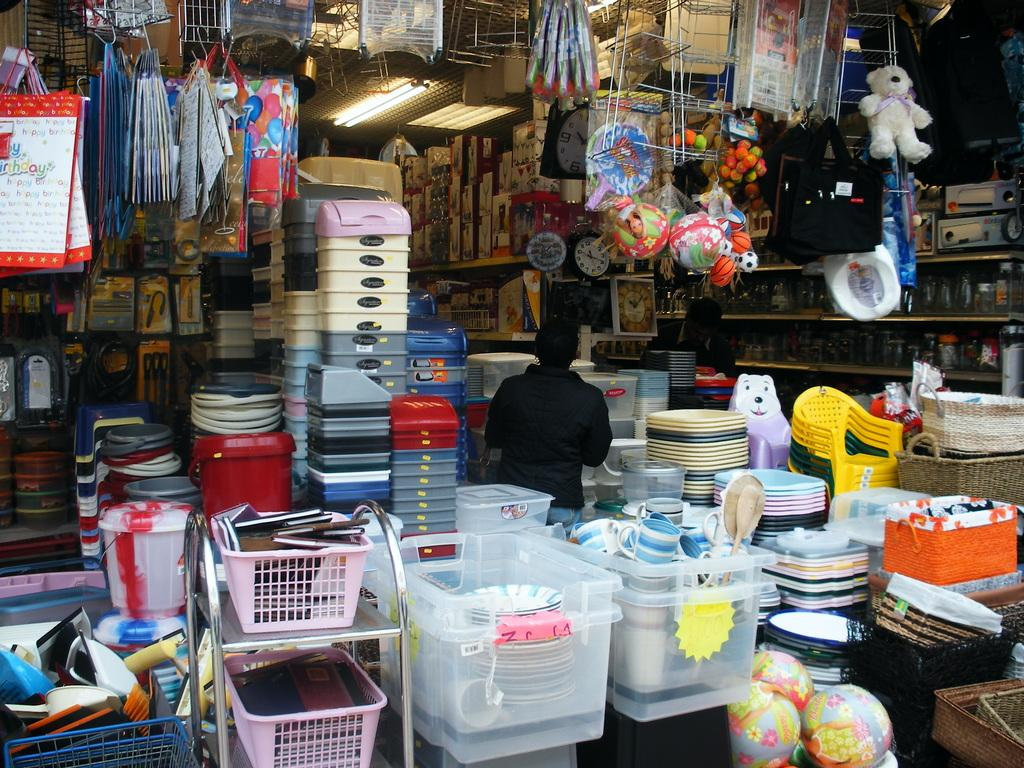<image>
Present a compact description of the photo's key features. A store full of party supply items, including a bag that says 'happy birthday' 